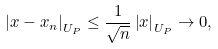Convert formula to latex. <formula><loc_0><loc_0><loc_500><loc_500>\left | x - x _ { n } \right | _ { U _ { P } } \leq \frac { 1 } { \sqrt { n } } \left | x \right | _ { U _ { P } } \rightarrow 0 ,</formula> 